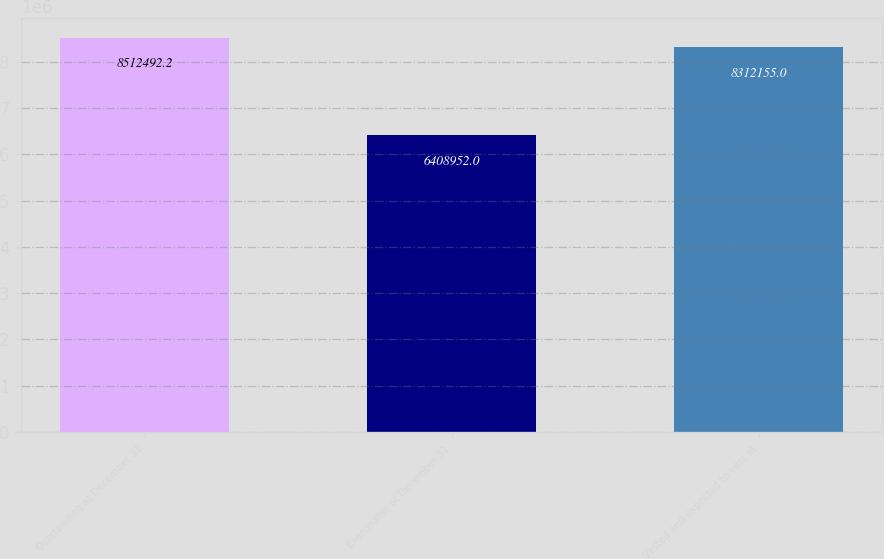Convert chart. <chart><loc_0><loc_0><loc_500><loc_500><bar_chart><fcel>Outstanding at December 31<fcel>Exercisable at December 31<fcel>Vested and expected to vest at<nl><fcel>8.51249e+06<fcel>6.40895e+06<fcel>8.31216e+06<nl></chart> 